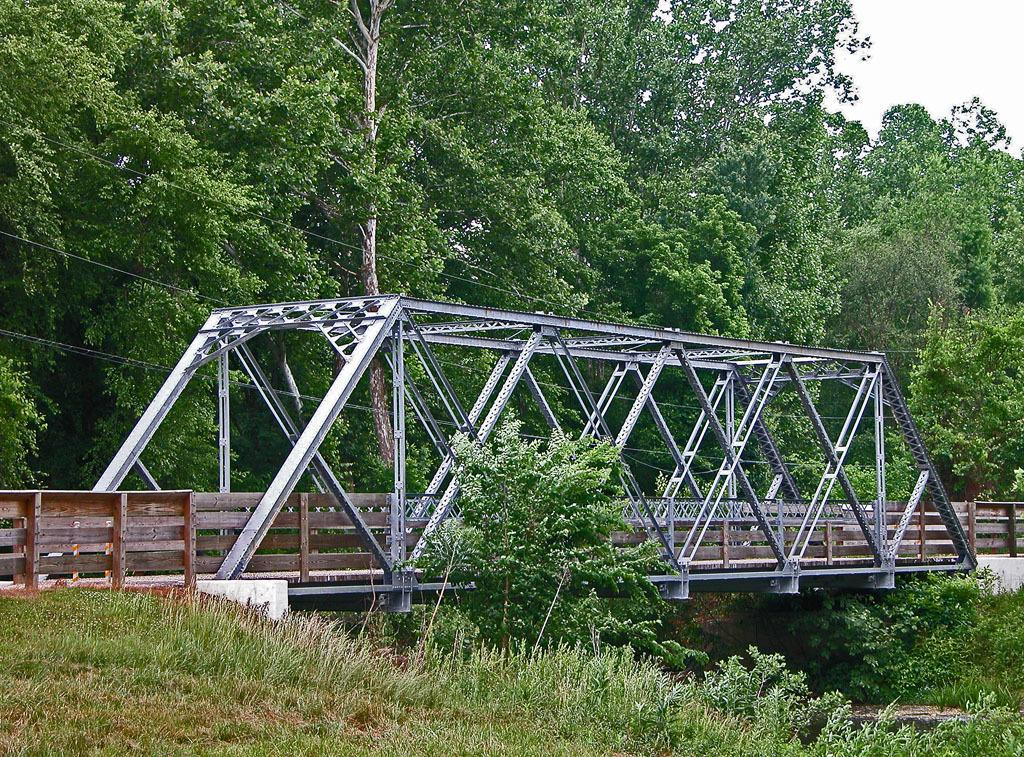What type of bridge is shown in the image? The bridge in the image is made up of metal and wood. What type of vegetation can be seen in the image? There is grass and trees visible in the image. What else is present in the image besides the bridge and vegetation? Electric wires are present in the image. What can be seen in the background of the image? The sky is visible in the image. Where is the store located in the image? There is no store present in the image. What type of card is being used to send mail in the image? There is no card or mailbox present in the image. 